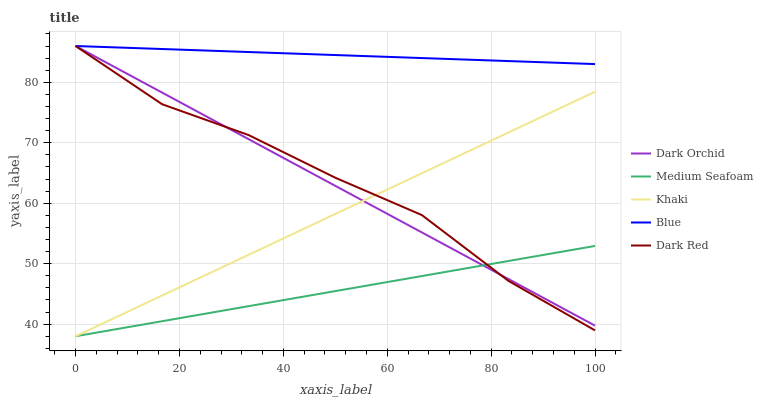Does Medium Seafoam have the minimum area under the curve?
Answer yes or no. Yes. Does Blue have the maximum area under the curve?
Answer yes or no. Yes. Does Dark Red have the minimum area under the curve?
Answer yes or no. No. Does Dark Red have the maximum area under the curve?
Answer yes or no. No. Is Dark Orchid the smoothest?
Answer yes or no. Yes. Is Dark Red the roughest?
Answer yes or no. Yes. Is Khaki the smoothest?
Answer yes or no. No. Is Khaki the roughest?
Answer yes or no. No. Does Khaki have the lowest value?
Answer yes or no. Yes. Does Dark Red have the lowest value?
Answer yes or no. No. Does Dark Orchid have the highest value?
Answer yes or no. Yes. Does Khaki have the highest value?
Answer yes or no. No. Is Khaki less than Blue?
Answer yes or no. Yes. Is Blue greater than Khaki?
Answer yes or no. Yes. Does Medium Seafoam intersect Dark Red?
Answer yes or no. Yes. Is Medium Seafoam less than Dark Red?
Answer yes or no. No. Is Medium Seafoam greater than Dark Red?
Answer yes or no. No. Does Khaki intersect Blue?
Answer yes or no. No. 